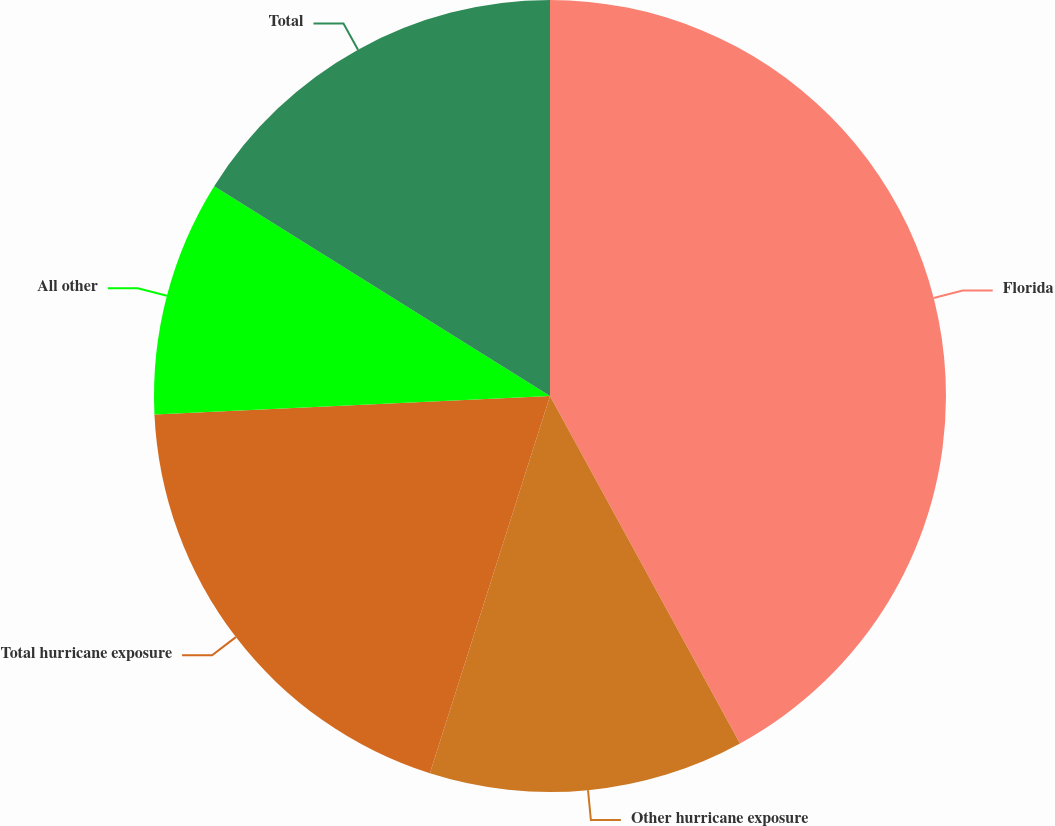<chart> <loc_0><loc_0><loc_500><loc_500><pie_chart><fcel>Florida<fcel>Other hurricane exposure<fcel>Total hurricane exposure<fcel>All other<fcel>Total<nl><fcel>42.03%<fcel>12.87%<fcel>19.35%<fcel>9.63%<fcel>16.11%<nl></chart> 